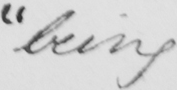What does this handwritten line say? " being 